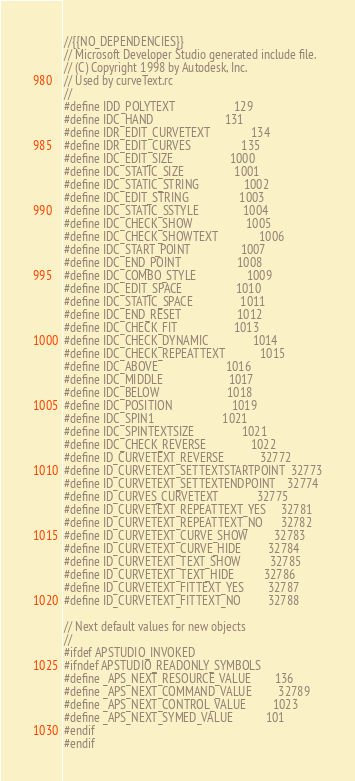<code> <loc_0><loc_0><loc_500><loc_500><_C_>//{{NO_DEPENDENCIES}}
// Microsoft Developer Studio generated include file.
// (C) Copyright 1998 by Autodesk, Inc.
// Used by curveText.rc
//
#define IDD_POLYTEXT                    129
#define IDC_HAND                        131
#define IDR_EDIT_CURVETEXT              134
#define IDR_EDIT_CURVES                 135
#define IDC_EDIT_SIZE                   1000
#define IDC_STATIC_SIZE                 1001
#define IDC_STATIC_STRING               1002
#define IDC_EDIT_STRING                 1003
#define IDC_STATIC_SSTYLE               1004
#define IDC_CHECK_SHOW                  1005
#define IDC_CHECK_SHOWTEXT              1006
#define IDC_START_POINT                 1007
#define IDC_END_POINT                   1008
#define IDC_COMBO_STYLE                 1009
#define IDC_EDIT_SPACE                  1010
#define IDC_STATIC_SPACE                1011
#define IDC_END_RESET                   1012
#define IDC_CHECK_FIT                   1013
#define IDC_CHECK_DYNAMIC               1014
#define IDC_CHECK_REPEATTEXT            1015
#define IDC_ABOVE                       1016
#define IDC_MIDDLE                      1017
#define IDC_BELOW                       1018
#define IDC_POSITION                    1019
#define IDC_SPIN1                       1021
#define IDC_SPINTEXTSIZE                1021
#define IDC_CHECK_REVERSE               1022
#define ID_CURVETEXT_REVERSE            32772
#define ID_CURVETEXT_SETTEXTSTARTPOINT  32773
#define ID_CURVETEXT_SETTEXTENDPOINT    32774
#define ID_CURVES_CURVETEXT             32775
#define ID_CURVETEXT_REPEATTEXT_YES     32781
#define ID_CURVETEXT_REPEATTEXT_NO      32782
#define ID_CURVETEXT_CURVE_SHOW         32783
#define ID_CURVETEXT_CURVE_HIDE         32784
#define ID_CURVETEXT_TEXT_SHOW          32785
#define ID_CURVETEXT_TEXT_HIDE          32786
#define ID_CURVETEXT_FITTEXT_YES        32787
#define ID_CURVETEXT_FITTEXT_NO         32788

// Next default values for new objects
// 
#ifdef APSTUDIO_INVOKED
#ifndef APSTUDIO_READONLY_SYMBOLS
#define _APS_NEXT_RESOURCE_VALUE        136
#define _APS_NEXT_COMMAND_VALUE         32789
#define _APS_NEXT_CONTROL_VALUE         1023
#define _APS_NEXT_SYMED_VALUE           101
#endif
#endif
</code> 